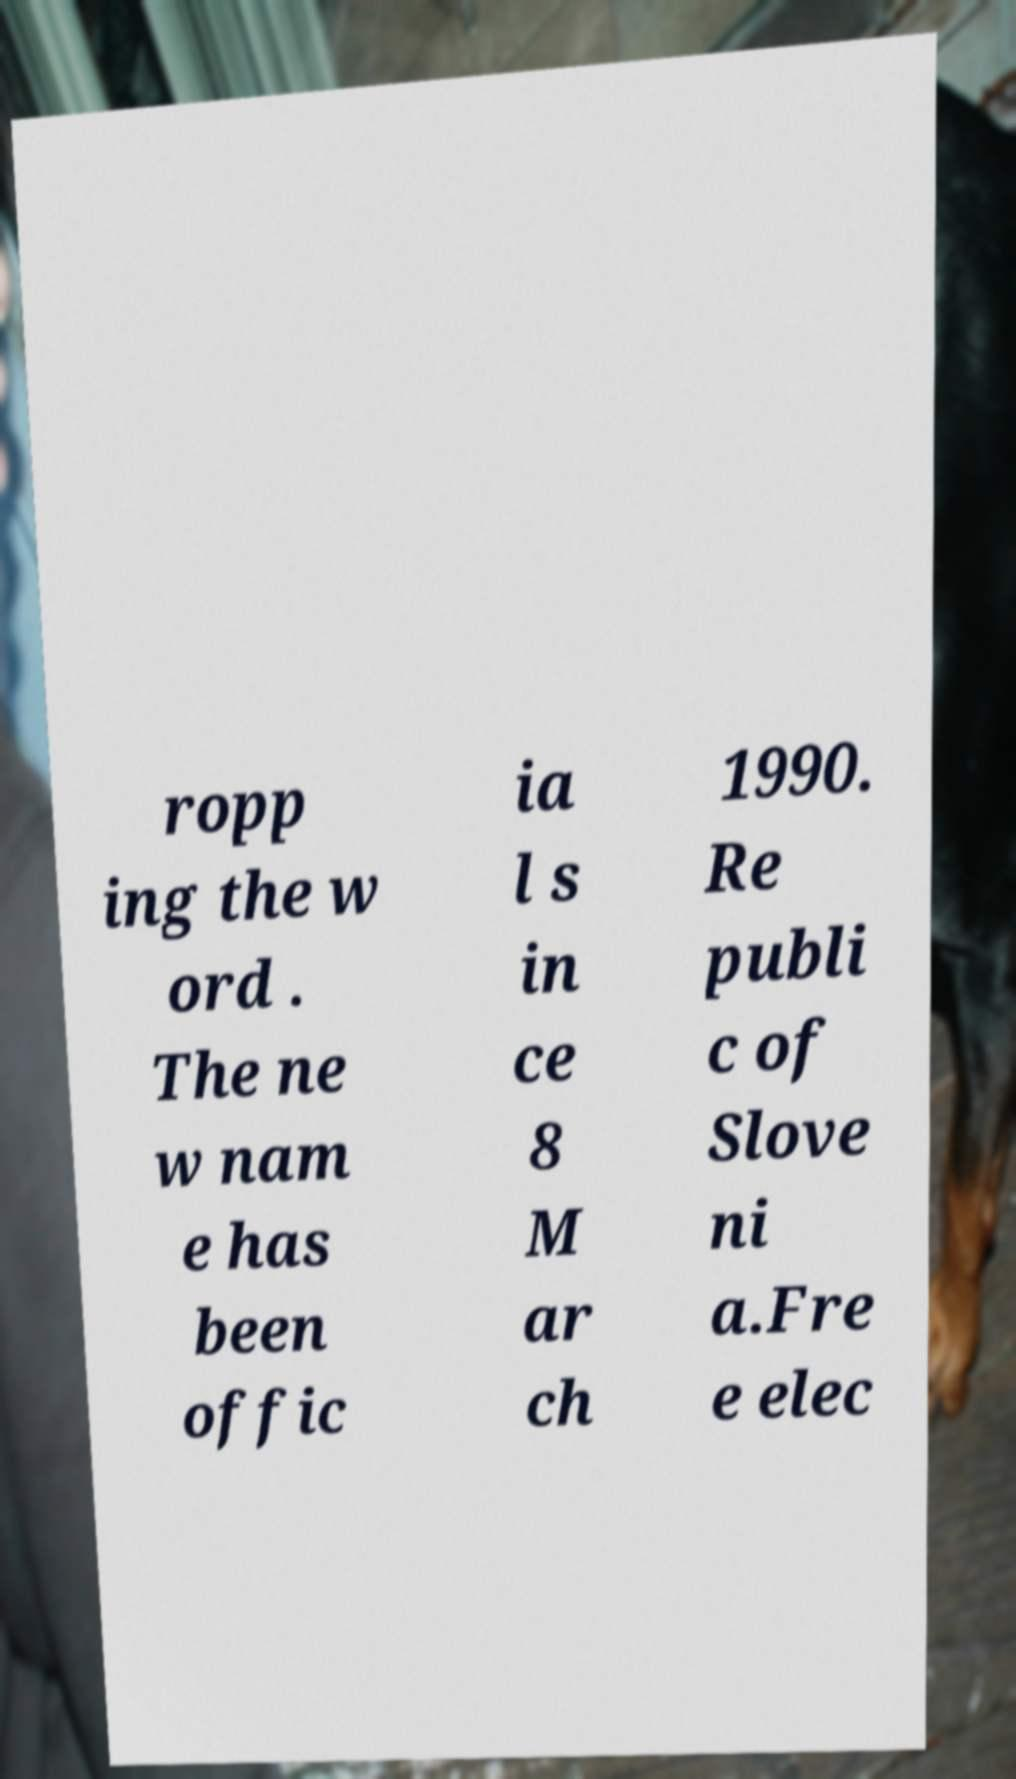Could you assist in decoding the text presented in this image and type it out clearly? ropp ing the w ord . The ne w nam e has been offic ia l s in ce 8 M ar ch 1990. Re publi c of Slove ni a.Fre e elec 